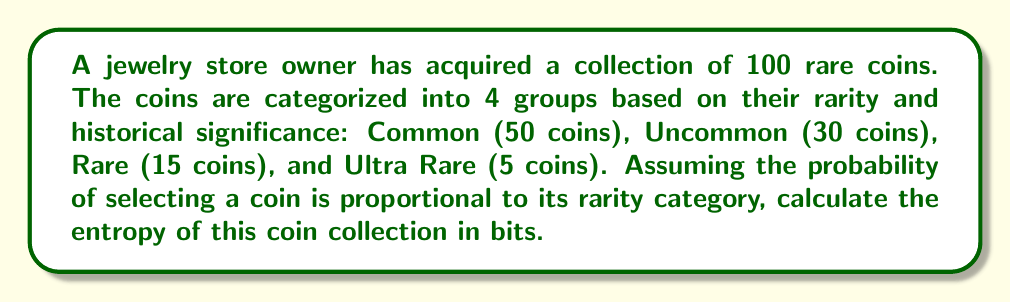Solve this math problem. To calculate the entropy of the coin collection, we'll use the formula for Shannon entropy:

$$H = -\sum_{i=1}^n p_i \log_2(p_i)$$

Where $p_i$ is the probability of selecting a coin from category $i$, and $n$ is the number of categories.

Step 1: Calculate the probabilities for each category
Common: $p_1 = 50/100 = 0.5$
Uncommon: $p_2 = 30/100 = 0.3$
Rare: $p_3 = 15/100 = 0.15$
Ultra Rare: $p_4 = 5/100 = 0.05$

Step 2: Calculate each term in the entropy sum
Common: $-0.5 \log_2(0.5) = 0.5$
Uncommon: $-0.3 \log_2(0.3) \approx 0.5211$
Rare: $-0.15 \log_2(0.15) \approx 0.4105$
Ultra Rare: $-0.05 \log_2(0.05) \approx 0.2161$

Step 3: Sum all terms
$$H = 0.5 + 0.5211 + 0.4105 + 0.2161 = 1.6477$$

Therefore, the entropy of the coin collection is approximately 1.6477 bits.
Answer: 1.6477 bits 